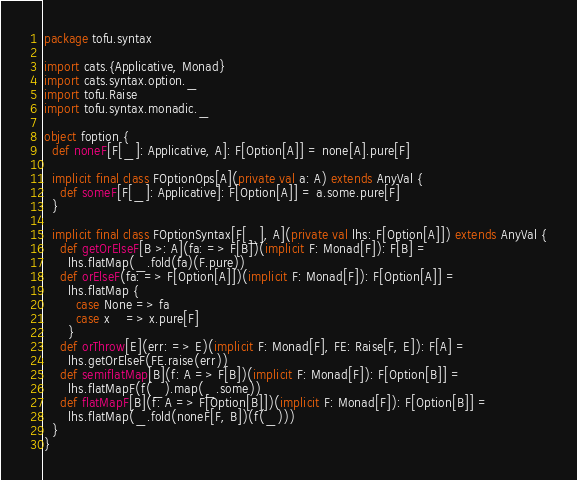<code> <loc_0><loc_0><loc_500><loc_500><_Scala_>package tofu.syntax

import cats.{Applicative, Monad}
import cats.syntax.option._
import tofu.Raise
import tofu.syntax.monadic._

object foption {
  def noneF[F[_]: Applicative, A]: F[Option[A]] = none[A].pure[F]

  implicit final class FOptionOps[A](private val a: A) extends AnyVal {
    def someF[F[_]: Applicative]: F[Option[A]] = a.some.pure[F]
  }

  implicit final class FOptionSyntax[F[_], A](private val lhs: F[Option[A]]) extends AnyVal {
    def getOrElseF[B >: A](fa: => F[B])(implicit F: Monad[F]): F[B] =
      lhs.flatMap(_.fold(fa)(F.pure))
    def orElseF(fa: => F[Option[A]])(implicit F: Monad[F]): F[Option[A]] =
      lhs.flatMap {
        case None => fa
        case x    => x.pure[F]
      }
    def orThrow[E](err: => E)(implicit F: Monad[F], FE: Raise[F, E]): F[A] =
      lhs.getOrElseF(FE.raise(err))
    def semiflatMap[B](f: A => F[B])(implicit F: Monad[F]): F[Option[B]] =
      lhs.flatMapF(f(_).map(_.some))
    def flatMapF[B](f: A => F[Option[B]])(implicit F: Monad[F]): F[Option[B]] =
      lhs.flatMap(_.fold(noneF[F, B])(f(_)))
  }
}
</code> 